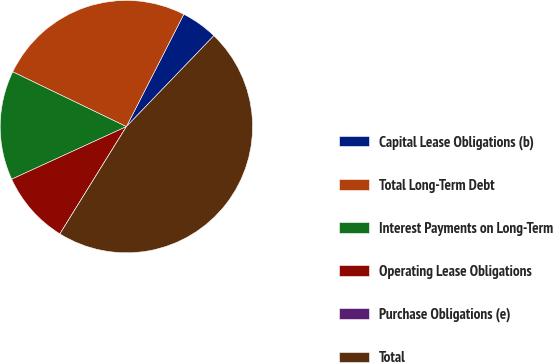Convert chart to OTSL. <chart><loc_0><loc_0><loc_500><loc_500><pie_chart><fcel>Capital Lease Obligations (b)<fcel>Total Long-Term Debt<fcel>Interest Payments on Long-Term<fcel>Operating Lease Obligations<fcel>Purchase Obligations (e)<fcel>Total<nl><fcel>4.67%<fcel>25.37%<fcel>13.99%<fcel>9.33%<fcel>0.0%<fcel>46.64%<nl></chart> 